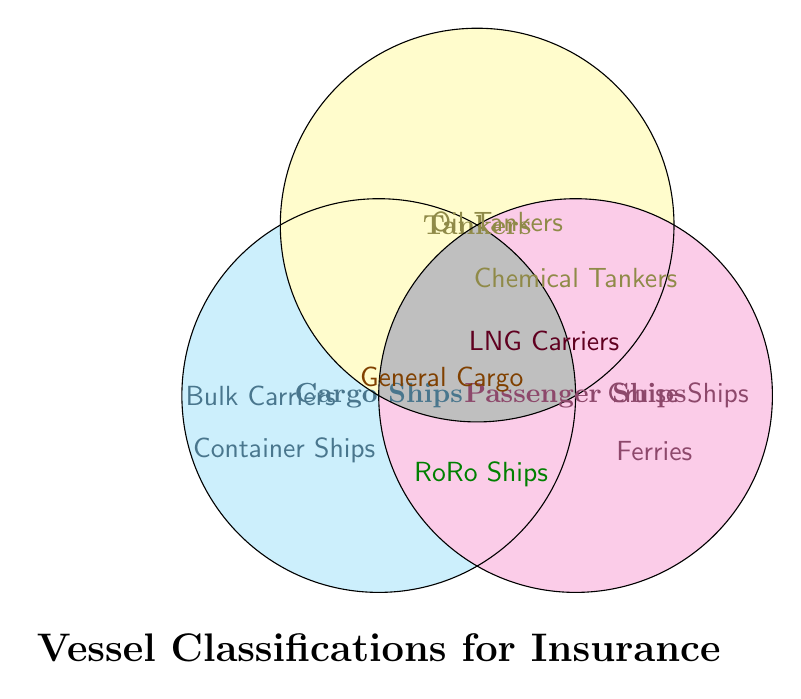Which categories overlap with General Cargo? General Cargo is located where the Cargo Ships and Tankers circles overlap.
Answer: Cargo Ships and Tankers Which vessel type is present in all three categories? The intersection of all three circles would indicate a vessel type present in all. None are located in that intersection.
Answer: None Where can you find RoRo Ships in the Venn Diagram? RoRo Ships are located in the overlapping area between Cargo Ships and Passenger Ships.
Answer: Cargo Ships and Passenger Ships How many types of ships are categorized as Passenger Ships only? Cruise Ships and Ferries are located solely within the Passenger Ships circle.
Answer: 2 Which ship types are common between Tankers and Passenger Ships? LNG Carriers are located in the overlapping area between Tankers and Passenger Ships.
Answer: LNG Carriers What category does Container Ships belong to? Container Ships are located within the Cargo Ships circle.
Answer: Cargo Ships Which category does not intersect with the other categories? All categories intersect with at least one other category in the diagram.
Answer: None Name a vessel type in the diagram categorized only as Tankers. Oil Tankers and Chemical Tankers are solely within the Tankers circle.
Answer: Oil Tankers, Chemical Tankers Do Bulk Carriers overlap with any other categories? Bulk Carriers are solely within the Cargo Ships circle, indicating no overlap.
Answer: No Identify a type of ship that falls into the intersection of Cargo Ships and Tankers but is not in Passenger Ships. General Cargo is located in the overlapping area between Cargo Ships and Tankers, but not within Passenger Ships.
Answer: General Cargo 